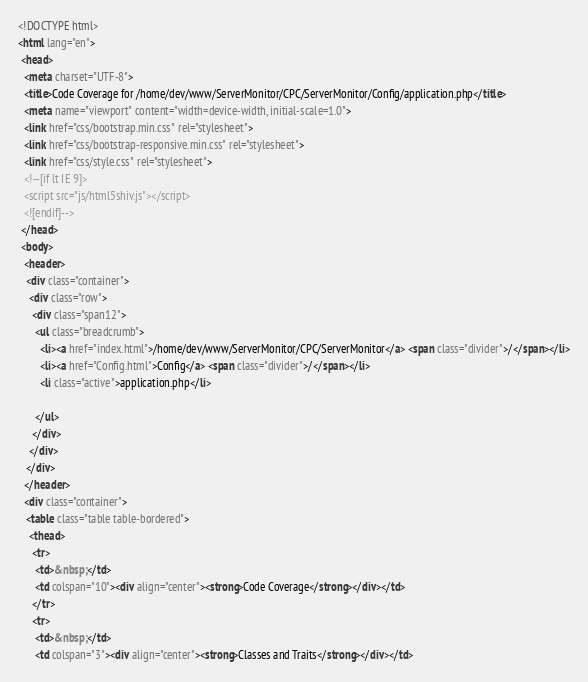<code> <loc_0><loc_0><loc_500><loc_500><_HTML_><!DOCTYPE html>
<html lang="en">
 <head>
  <meta charset="UTF-8">
  <title>Code Coverage for /home/dev/www/ServerMonitor/CPC/ServerMonitor/Config/application.php</title>
  <meta name="viewport" content="width=device-width, initial-scale=1.0">
  <link href="css/bootstrap.min.css" rel="stylesheet">
  <link href="css/bootstrap-responsive.min.css" rel="stylesheet">
  <link href="css/style.css" rel="stylesheet">
  <!--[if lt IE 9]>
  <script src="js/html5shiv.js"></script>
  <![endif]-->
 </head>
 <body>
  <header>
   <div class="container">
    <div class="row">
     <div class="span12">
      <ul class="breadcrumb">
        <li><a href="index.html">/home/dev/www/ServerMonitor/CPC/ServerMonitor</a> <span class="divider">/</span></li>
        <li><a href="Config.html">Config</a> <span class="divider">/</span></li>
        <li class="active">application.php</li>

      </ul>
     </div>
    </div>
   </div>
  </header>
  <div class="container">
   <table class="table table-bordered">
    <thead>
     <tr>
      <td>&nbsp;</td>
      <td colspan="10"><div align="center"><strong>Code Coverage</strong></div></td>
     </tr>
     <tr>
      <td>&nbsp;</td>
      <td colspan="3"><div align="center"><strong>Classes and Traits</strong></div></td></code> 